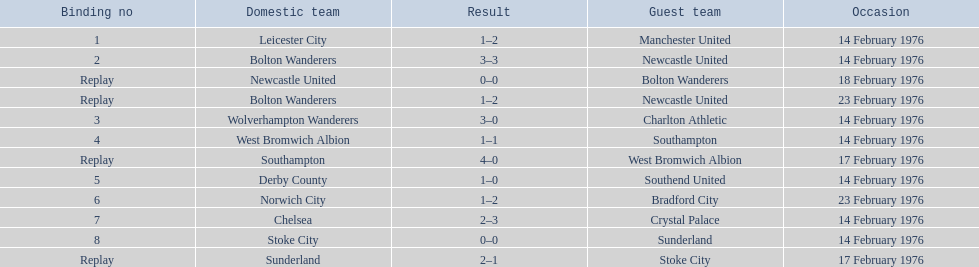Who were all of the teams? Leicester City, Manchester United, Bolton Wanderers, Newcastle United, Newcastle United, Bolton Wanderers, Bolton Wanderers, Newcastle United, Wolverhampton Wanderers, Charlton Athletic, West Bromwich Albion, Southampton, Southampton, West Bromwich Albion, Derby County, Southend United, Norwich City, Bradford City, Chelsea, Crystal Palace, Stoke City, Sunderland, Sunderland, Stoke City. And what were their scores? 1–2, 3–3, 0–0, 1–2, 3–0, 1–1, 4–0, 1–0, 1–2, 2–3, 0–0, 2–1. Between manchester and wolverhampton, who scored more? Wolverhampton Wanderers. 